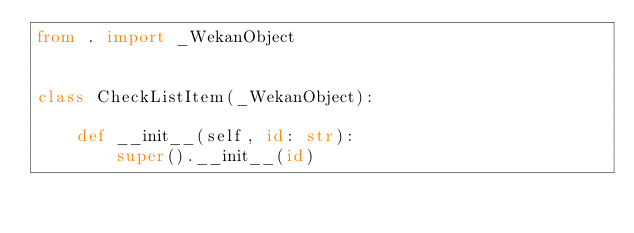<code> <loc_0><loc_0><loc_500><loc_500><_Python_>from . import _WekanObject


class CheckListItem(_WekanObject):

    def __init__(self, id: str):
        super().__init__(id)
</code> 